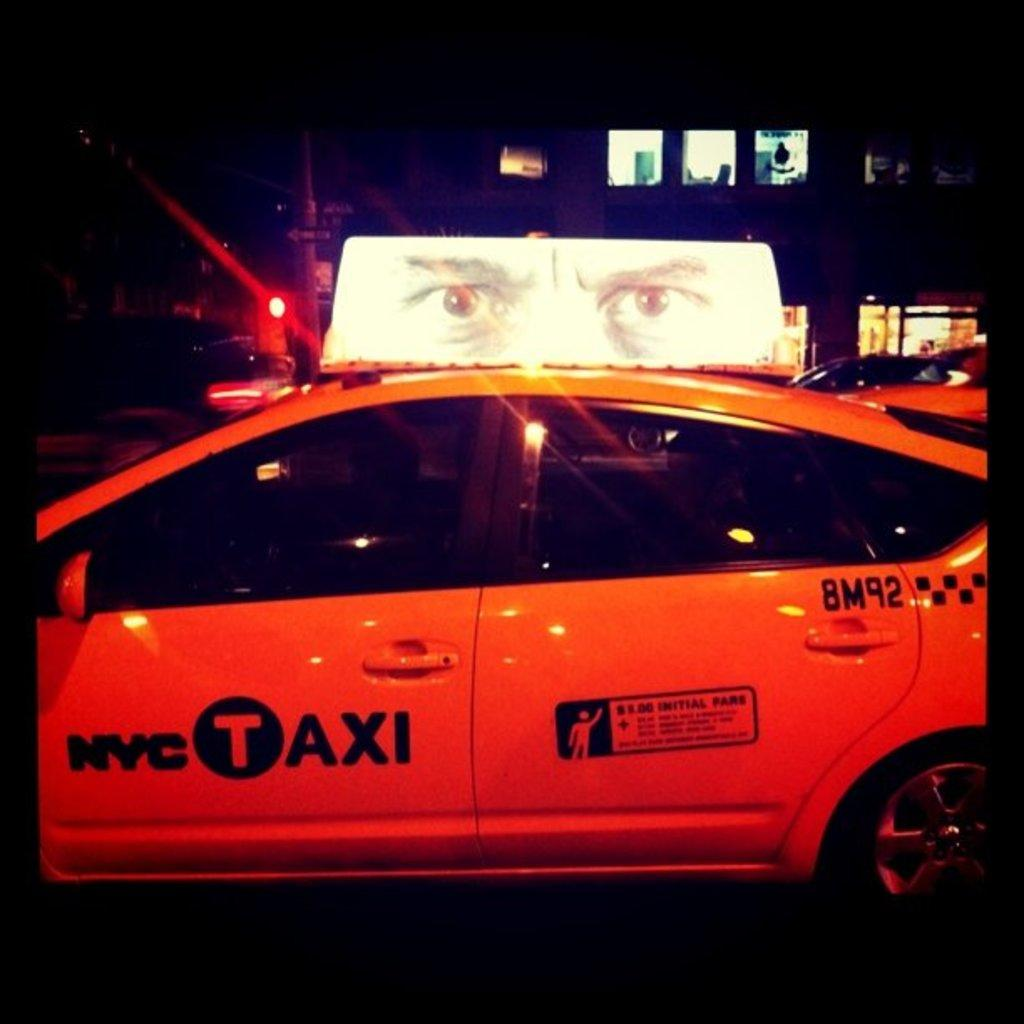<image>
Offer a succinct explanation of the picture presented. A yellow car with a sign on top says NYC Taxi. 